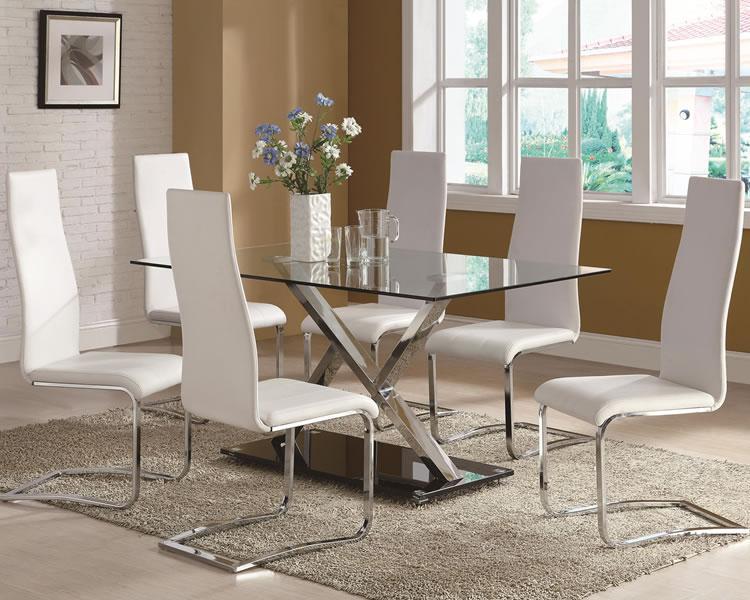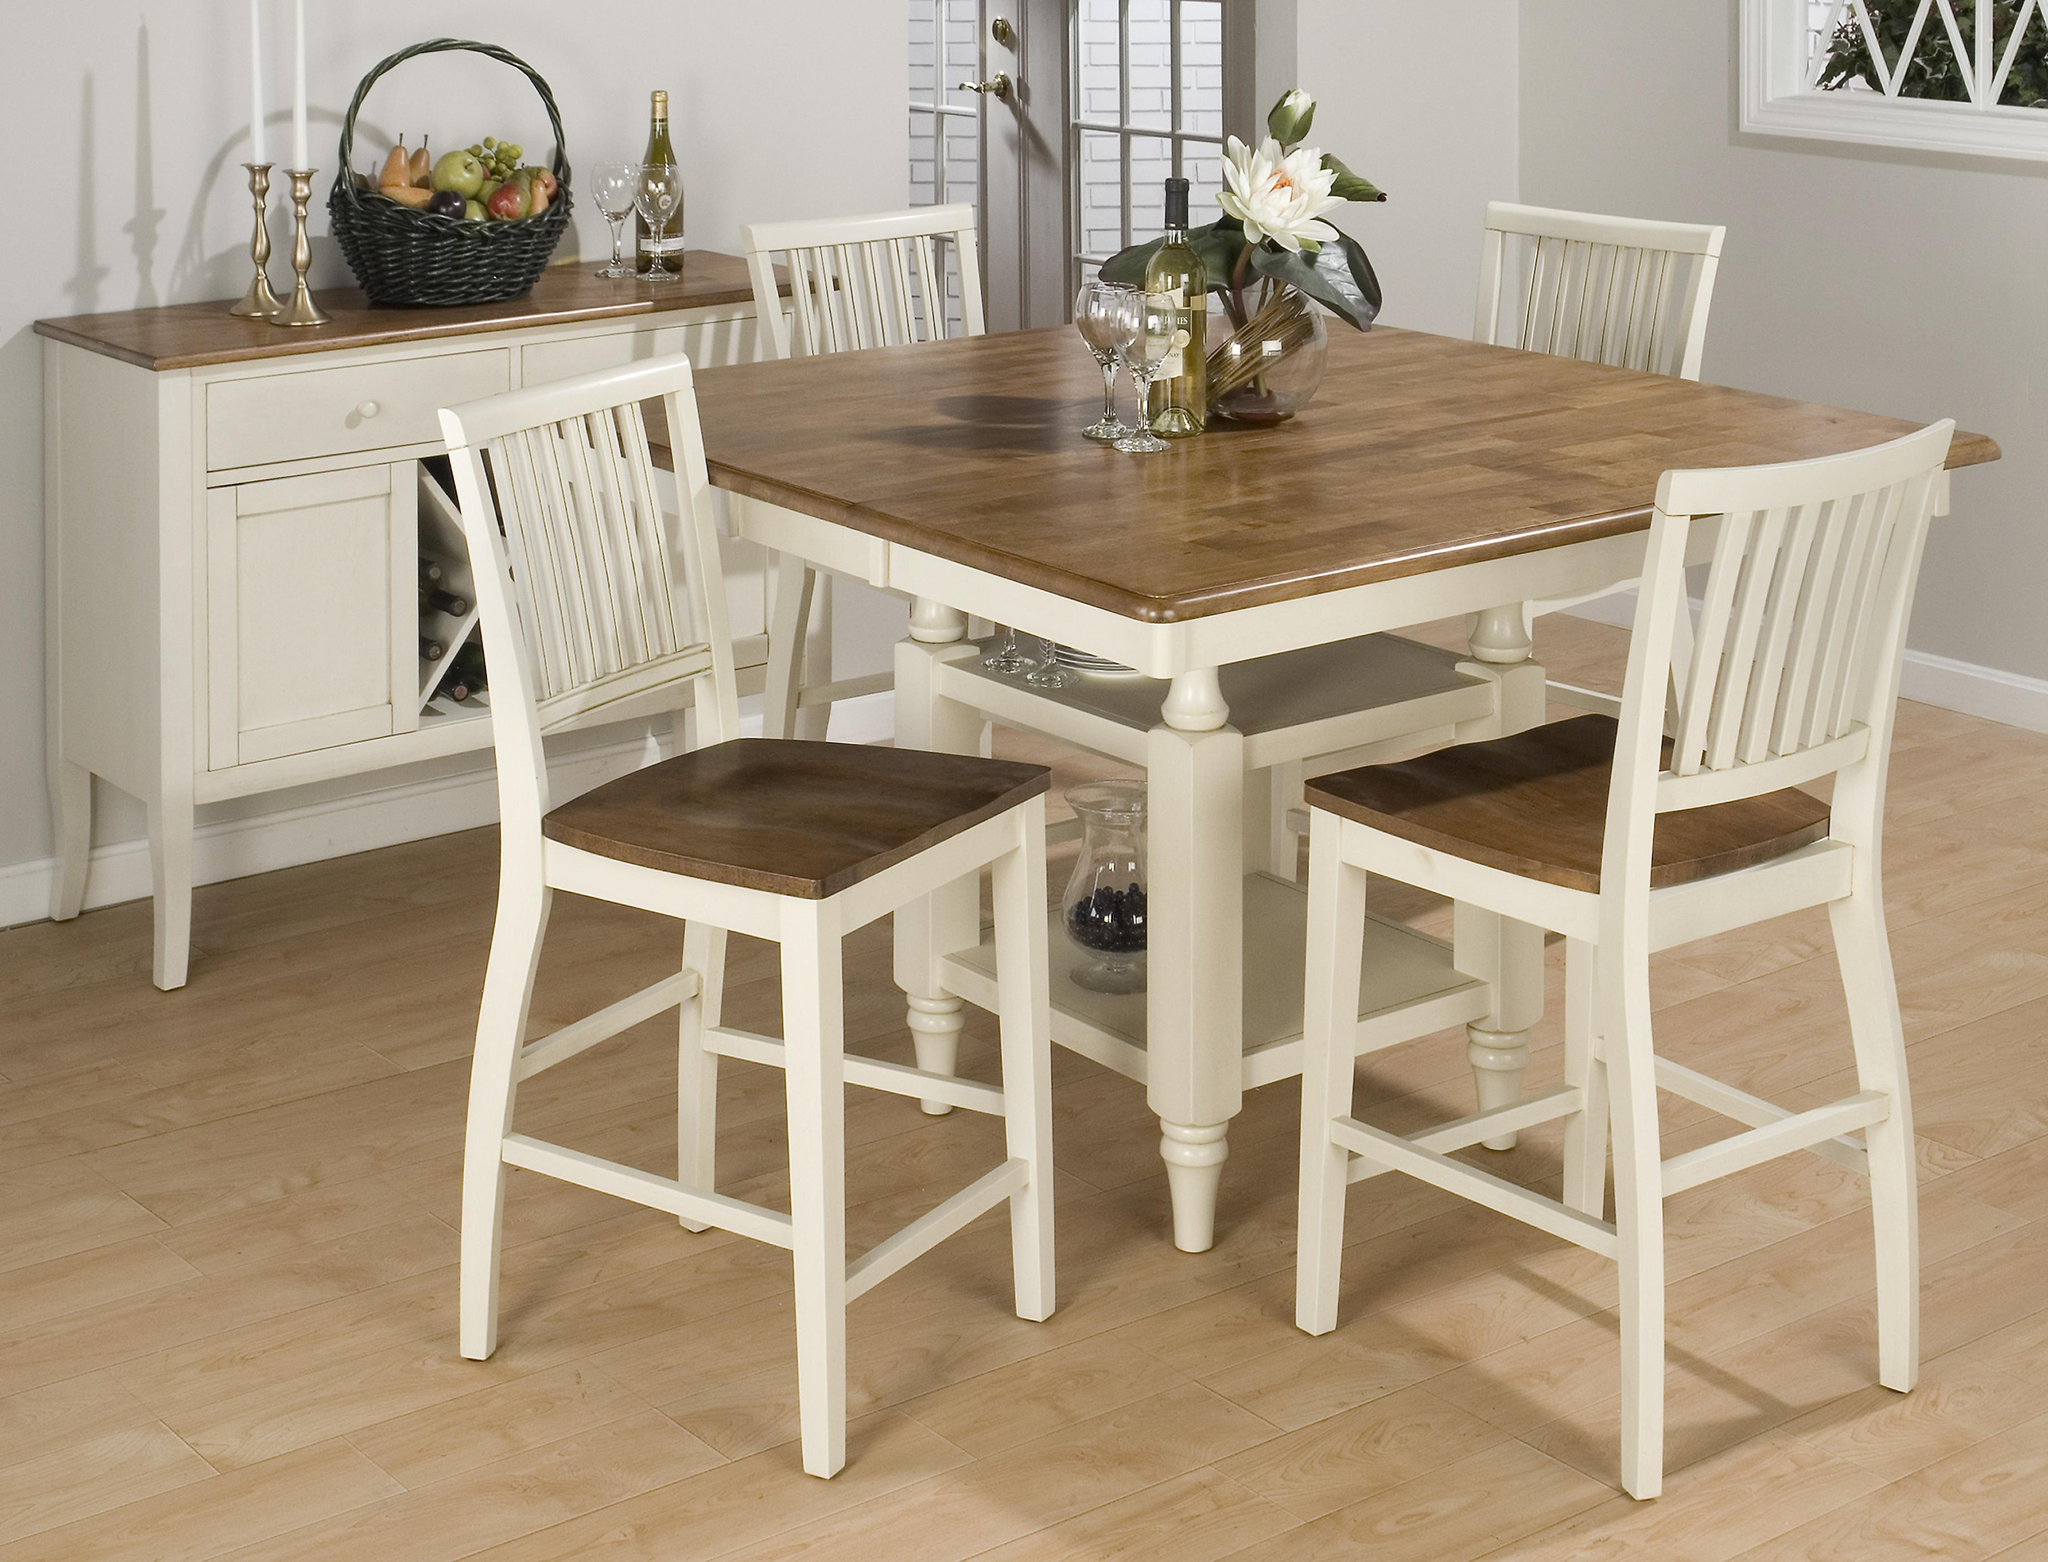The first image is the image on the left, the second image is the image on the right. Evaluate the accuracy of this statement regarding the images: "In one of the images, two different styles of seating are available around a single table.". Is it true? Answer yes or no. No. The first image is the image on the left, the second image is the image on the right. Evaluate the accuracy of this statement regarding the images: "One image shows a brown topped white table with six white chairs with brown seats around it, and the other image shows a non-round table with a bench on one side and at least three chairs with multiple rails across the back.". Is it true? Answer yes or no. No. 